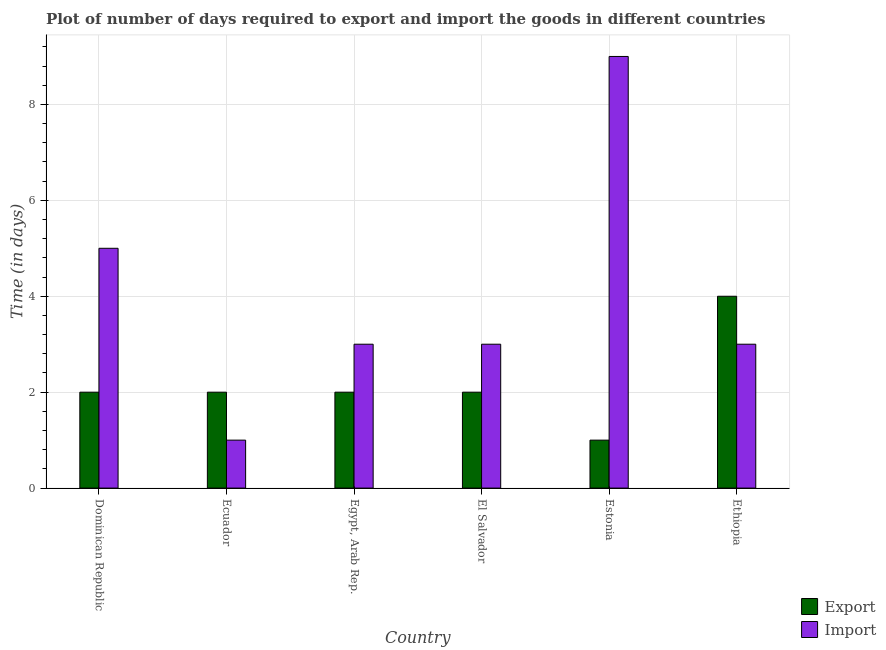How many different coloured bars are there?
Your answer should be compact. 2. How many groups of bars are there?
Your answer should be very brief. 6. Are the number of bars per tick equal to the number of legend labels?
Give a very brief answer. Yes. Are the number of bars on each tick of the X-axis equal?
Your answer should be very brief. Yes. How many bars are there on the 2nd tick from the right?
Offer a terse response. 2. What is the label of the 3rd group of bars from the left?
Keep it short and to the point. Egypt, Arab Rep. In how many cases, is the number of bars for a given country not equal to the number of legend labels?
Give a very brief answer. 0. What is the time required to import in Estonia?
Your answer should be compact. 9. Across all countries, what is the minimum time required to import?
Make the answer very short. 1. In which country was the time required to import maximum?
Keep it short and to the point. Estonia. In which country was the time required to import minimum?
Make the answer very short. Ecuador. What is the total time required to import in the graph?
Make the answer very short. 24. What is the difference between the time required to import in El Salvador and that in Estonia?
Your response must be concise. -6. What is the difference between the time required to import in Ecuador and the time required to export in El Salvador?
Your answer should be compact. -1. What is the average time required to export per country?
Provide a succinct answer. 2.17. In how many countries, is the time required to import greater than 4 days?
Provide a succinct answer. 2. What is the difference between the highest and the lowest time required to export?
Ensure brevity in your answer.  3. What does the 1st bar from the left in Ecuador represents?
Provide a succinct answer. Export. What does the 2nd bar from the right in Ecuador represents?
Your answer should be compact. Export. Does the graph contain grids?
Give a very brief answer. Yes. How many legend labels are there?
Make the answer very short. 2. What is the title of the graph?
Provide a short and direct response. Plot of number of days required to export and import the goods in different countries. Does "Not attending school" appear as one of the legend labels in the graph?
Offer a terse response. No. What is the label or title of the Y-axis?
Your answer should be very brief. Time (in days). What is the Time (in days) of Import in Ecuador?
Give a very brief answer. 1. What is the Time (in days) in Export in El Salvador?
Provide a succinct answer. 2. What is the Time (in days) in Import in El Salvador?
Keep it short and to the point. 3. What is the Time (in days) in Export in Estonia?
Give a very brief answer. 1. What is the Time (in days) in Import in Estonia?
Ensure brevity in your answer.  9. What is the Time (in days) in Export in Ethiopia?
Provide a short and direct response. 4. Across all countries, what is the maximum Time (in days) of Export?
Your response must be concise. 4. Across all countries, what is the maximum Time (in days) in Import?
Provide a succinct answer. 9. Across all countries, what is the minimum Time (in days) in Export?
Your answer should be compact. 1. What is the difference between the Time (in days) in Export in Dominican Republic and that in Egypt, Arab Rep.?
Your response must be concise. 0. What is the difference between the Time (in days) in Export in Dominican Republic and that in El Salvador?
Your answer should be very brief. 0. What is the difference between the Time (in days) of Import in Dominican Republic and that in El Salvador?
Your response must be concise. 2. What is the difference between the Time (in days) of Import in Dominican Republic and that in Estonia?
Provide a succinct answer. -4. What is the difference between the Time (in days) of Import in Dominican Republic and that in Ethiopia?
Provide a succinct answer. 2. What is the difference between the Time (in days) in Export in Ecuador and that in Egypt, Arab Rep.?
Ensure brevity in your answer.  0. What is the difference between the Time (in days) of Import in Ecuador and that in Egypt, Arab Rep.?
Offer a terse response. -2. What is the difference between the Time (in days) of Export in Ecuador and that in El Salvador?
Make the answer very short. 0. What is the difference between the Time (in days) of Import in Ecuador and that in El Salvador?
Your answer should be compact. -2. What is the difference between the Time (in days) of Export in Ecuador and that in Estonia?
Your answer should be very brief. 1. What is the difference between the Time (in days) of Import in Ecuador and that in Estonia?
Give a very brief answer. -8. What is the difference between the Time (in days) in Import in Ecuador and that in Ethiopia?
Ensure brevity in your answer.  -2. What is the difference between the Time (in days) in Export in Egypt, Arab Rep. and that in El Salvador?
Keep it short and to the point. 0. What is the difference between the Time (in days) of Import in Egypt, Arab Rep. and that in El Salvador?
Keep it short and to the point. 0. What is the difference between the Time (in days) in Export in Egypt, Arab Rep. and that in Estonia?
Provide a succinct answer. 1. What is the difference between the Time (in days) in Import in Egypt, Arab Rep. and that in Estonia?
Your answer should be very brief. -6. What is the difference between the Time (in days) of Export in Egypt, Arab Rep. and that in Ethiopia?
Your answer should be compact. -2. What is the difference between the Time (in days) in Import in Egypt, Arab Rep. and that in Ethiopia?
Keep it short and to the point. 0. What is the difference between the Time (in days) of Export in El Salvador and that in Estonia?
Ensure brevity in your answer.  1. What is the difference between the Time (in days) of Import in El Salvador and that in Estonia?
Your answer should be very brief. -6. What is the difference between the Time (in days) of Export in El Salvador and that in Ethiopia?
Provide a short and direct response. -2. What is the difference between the Time (in days) of Import in El Salvador and that in Ethiopia?
Your answer should be compact. 0. What is the difference between the Time (in days) of Import in Estonia and that in Ethiopia?
Make the answer very short. 6. What is the difference between the Time (in days) in Export in Dominican Republic and the Time (in days) in Import in Ecuador?
Ensure brevity in your answer.  1. What is the difference between the Time (in days) in Export in Ecuador and the Time (in days) in Import in Egypt, Arab Rep.?
Your answer should be compact. -1. What is the difference between the Time (in days) of Export in Ecuador and the Time (in days) of Import in El Salvador?
Make the answer very short. -1. What is the difference between the Time (in days) of Export in Ecuador and the Time (in days) of Import in Estonia?
Keep it short and to the point. -7. What is the difference between the Time (in days) in Export in Ecuador and the Time (in days) in Import in Ethiopia?
Give a very brief answer. -1. What is the difference between the Time (in days) of Export in Egypt, Arab Rep. and the Time (in days) of Import in El Salvador?
Keep it short and to the point. -1. What is the difference between the Time (in days) in Export in Egypt, Arab Rep. and the Time (in days) in Import in Estonia?
Provide a succinct answer. -7. What is the difference between the Time (in days) in Export in El Salvador and the Time (in days) in Import in Estonia?
Give a very brief answer. -7. What is the difference between the Time (in days) in Export in Estonia and the Time (in days) in Import in Ethiopia?
Provide a succinct answer. -2. What is the average Time (in days) of Export per country?
Keep it short and to the point. 2.17. What is the average Time (in days) of Import per country?
Offer a very short reply. 4. What is the difference between the Time (in days) in Export and Time (in days) in Import in Dominican Republic?
Provide a short and direct response. -3. What is the difference between the Time (in days) in Export and Time (in days) in Import in Ecuador?
Provide a succinct answer. 1. What is the difference between the Time (in days) in Export and Time (in days) in Import in Egypt, Arab Rep.?
Keep it short and to the point. -1. What is the difference between the Time (in days) in Export and Time (in days) in Import in Estonia?
Your answer should be compact. -8. What is the difference between the Time (in days) of Export and Time (in days) of Import in Ethiopia?
Make the answer very short. 1. What is the ratio of the Time (in days) in Export in Dominican Republic to that in Ecuador?
Your answer should be very brief. 1. What is the ratio of the Time (in days) of Export in Dominican Republic to that in Egypt, Arab Rep.?
Offer a terse response. 1. What is the ratio of the Time (in days) in Import in Dominican Republic to that in El Salvador?
Offer a terse response. 1.67. What is the ratio of the Time (in days) in Import in Dominican Republic to that in Estonia?
Provide a succinct answer. 0.56. What is the ratio of the Time (in days) of Export in Dominican Republic to that in Ethiopia?
Keep it short and to the point. 0.5. What is the ratio of the Time (in days) in Import in Dominican Republic to that in Ethiopia?
Offer a very short reply. 1.67. What is the ratio of the Time (in days) in Export in Ecuador to that in Egypt, Arab Rep.?
Give a very brief answer. 1. What is the ratio of the Time (in days) of Import in Ecuador to that in Egypt, Arab Rep.?
Offer a very short reply. 0.33. What is the ratio of the Time (in days) in Export in Ecuador to that in Estonia?
Make the answer very short. 2. What is the ratio of the Time (in days) in Import in Egypt, Arab Rep. to that in El Salvador?
Give a very brief answer. 1. What is the ratio of the Time (in days) in Export in Egypt, Arab Rep. to that in Estonia?
Ensure brevity in your answer.  2. What is the ratio of the Time (in days) of Import in Egypt, Arab Rep. to that in Estonia?
Offer a very short reply. 0.33. What is the ratio of the Time (in days) of Import in El Salvador to that in Ethiopia?
Provide a succinct answer. 1. What is the ratio of the Time (in days) in Import in Estonia to that in Ethiopia?
Your answer should be very brief. 3. What is the difference between the highest and the second highest Time (in days) in Export?
Your response must be concise. 2. What is the difference between the highest and the second highest Time (in days) of Import?
Your answer should be very brief. 4. What is the difference between the highest and the lowest Time (in days) in Export?
Ensure brevity in your answer.  3. 